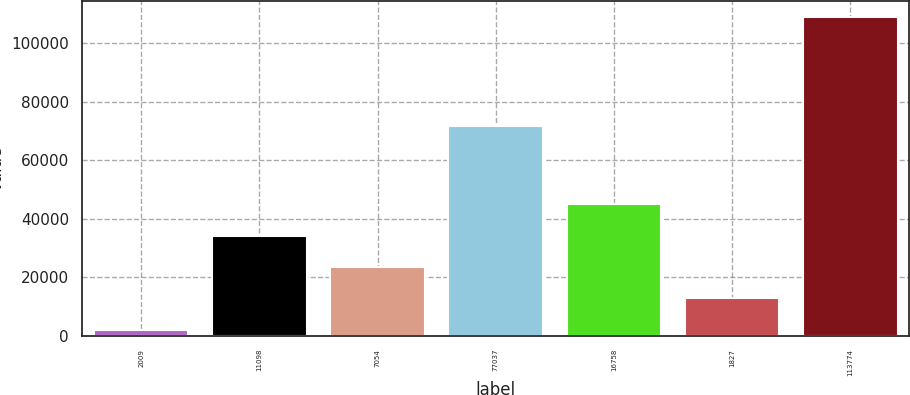<chart> <loc_0><loc_0><loc_500><loc_500><bar_chart><fcel>2009<fcel>11098<fcel>7054<fcel>77037<fcel>16758<fcel>1827<fcel>113774<nl><fcel>2007<fcel>34145.4<fcel>23432.6<fcel>71558<fcel>44858.2<fcel>12719.8<fcel>109135<nl></chart> 